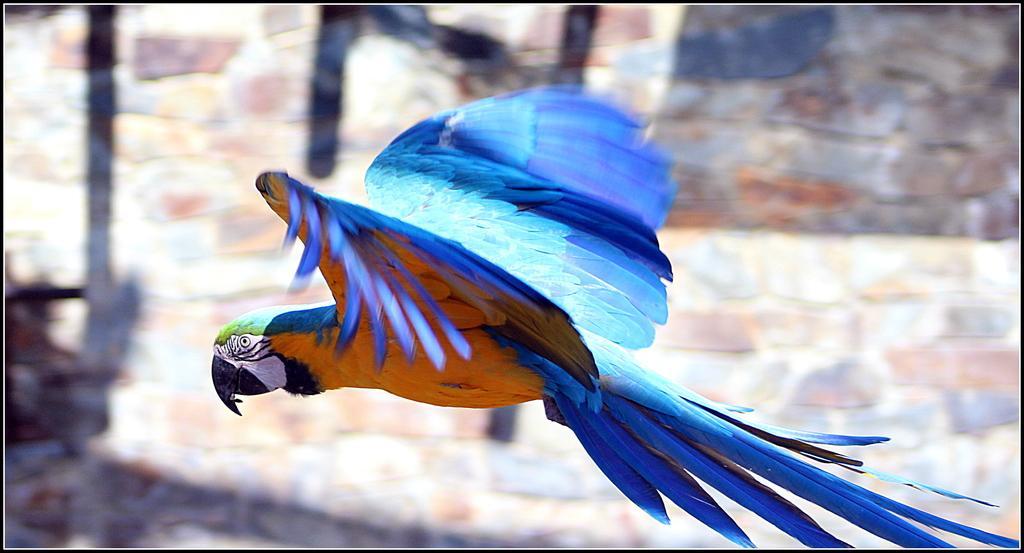Could you give a brief overview of what you see in this image? In the picture we can see a parrot which is flying in the air, the parrot is white, black, yellow and some part blue in color and the beak is black in color, in the background we can see a wall with stones. 